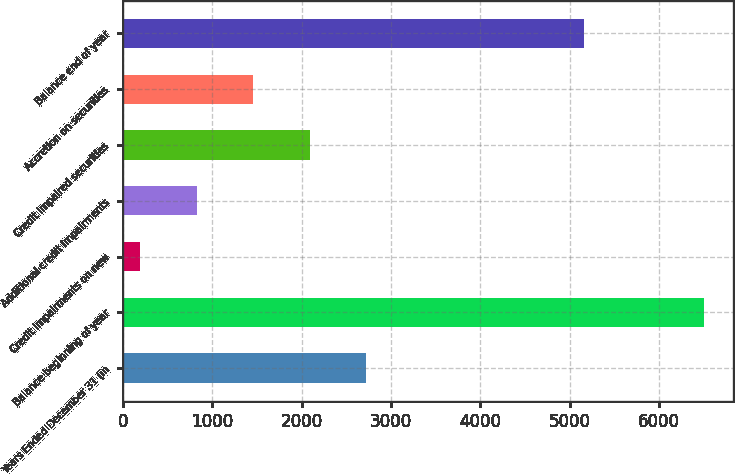Convert chart to OTSL. <chart><loc_0><loc_0><loc_500><loc_500><bar_chart><fcel>Years Ended December 31 (in<fcel>Balance beginning of year<fcel>Credit impairments on new<fcel>Additional credit impairments<fcel>Credit impaired securities<fcel>Accretion on securities<fcel>Balance end of year<nl><fcel>2718<fcel>6504<fcel>194<fcel>825<fcel>2087<fcel>1456<fcel>5164<nl></chart> 